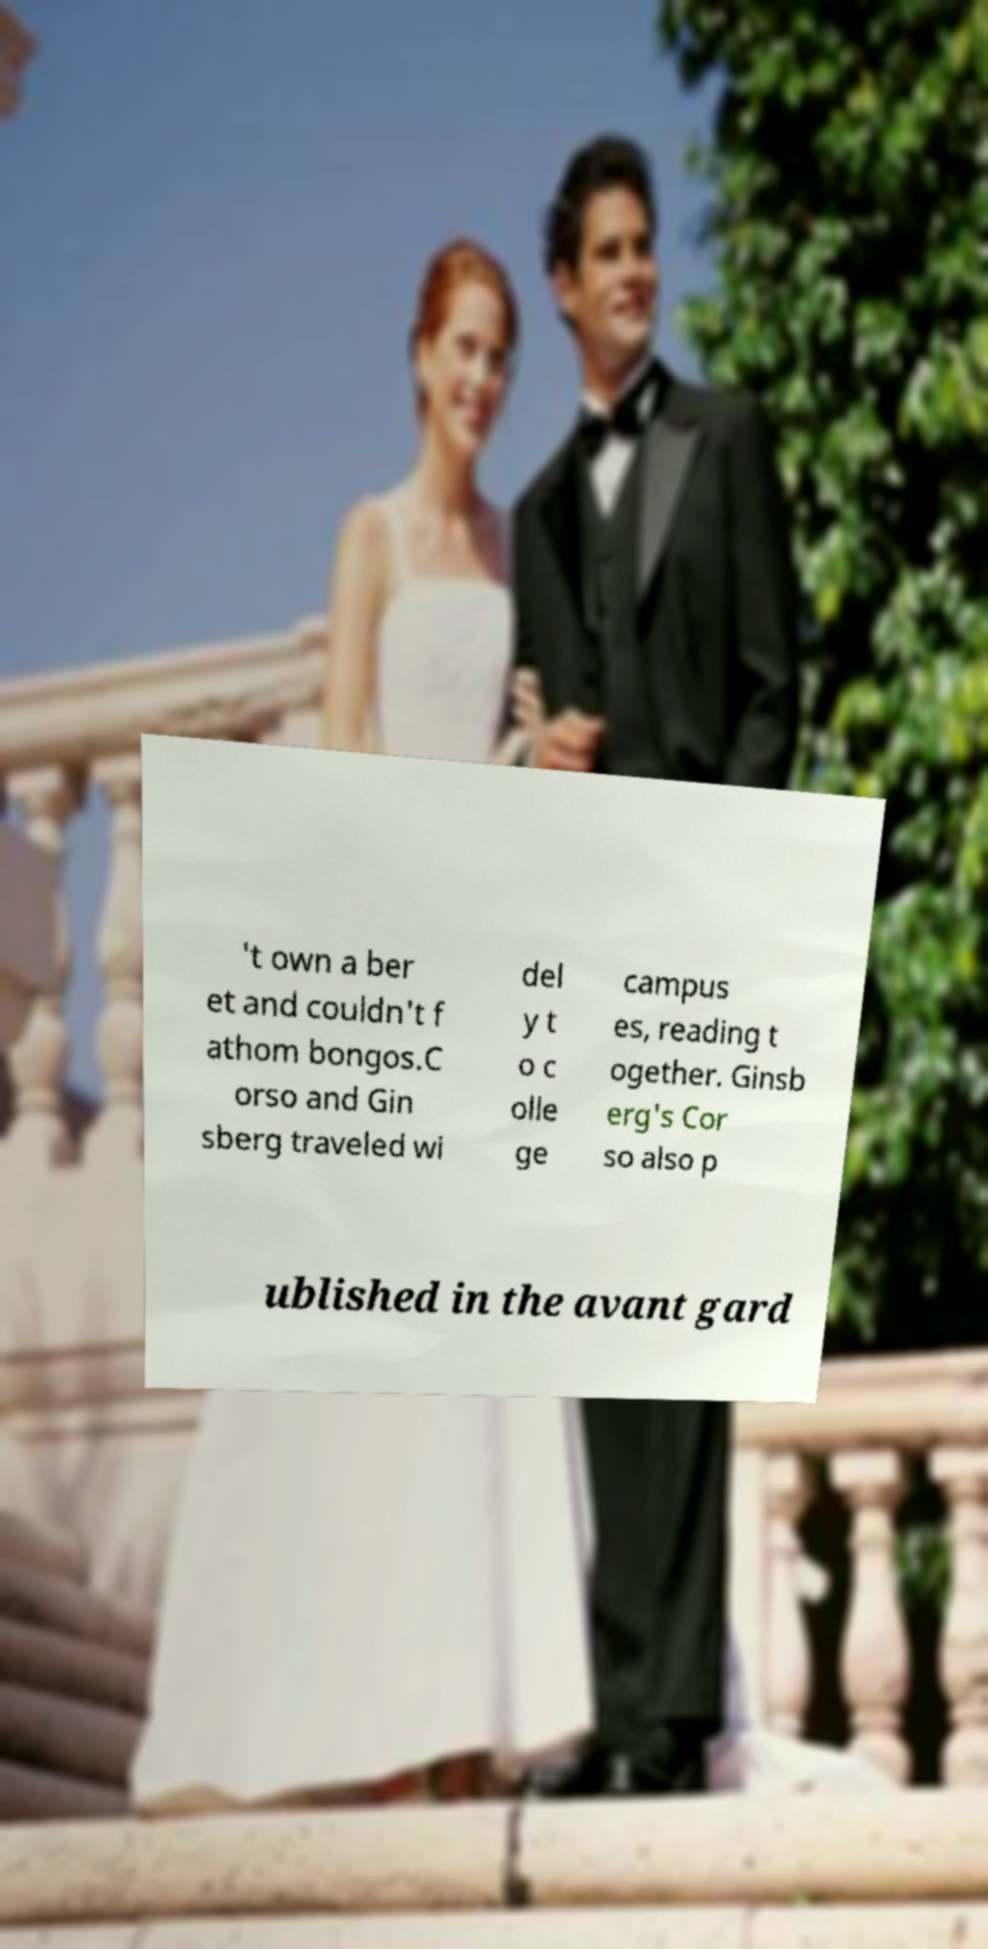Can you read and provide the text displayed in the image?This photo seems to have some interesting text. Can you extract and type it out for me? 't own a ber et and couldn't f athom bongos.C orso and Gin sberg traveled wi del y t o c olle ge campus es, reading t ogether. Ginsb erg's Cor so also p ublished in the avant gard 